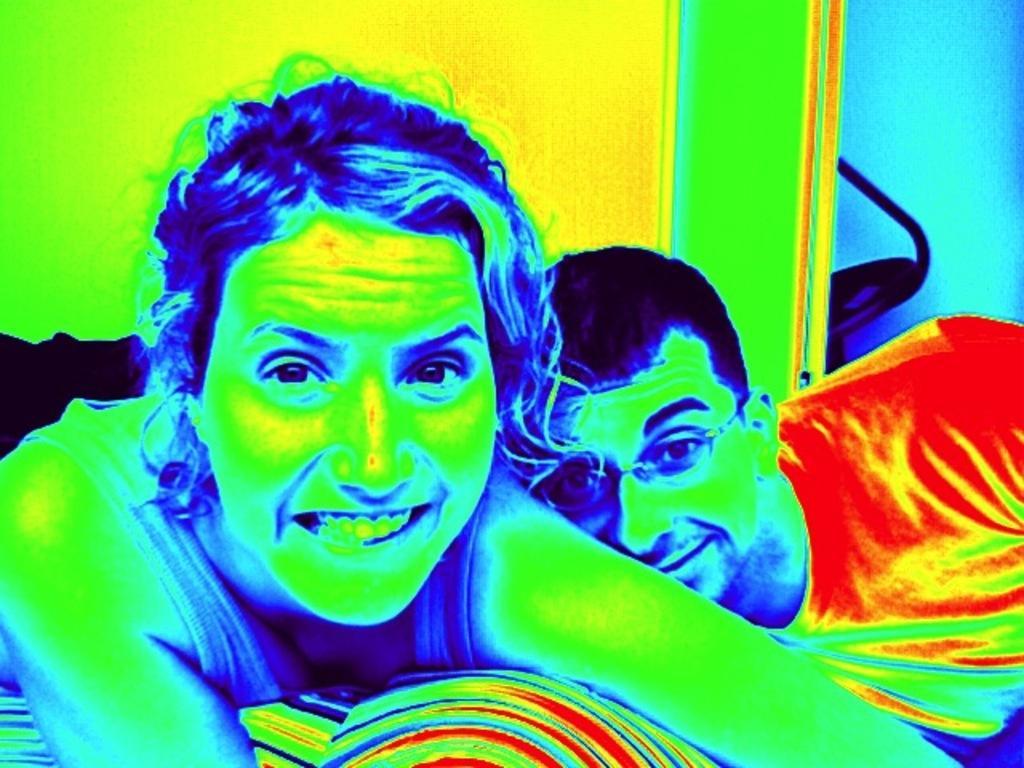Can you describe this image briefly? In this image I can see two people a man and a woman posing for the picture. This is an edited image. 